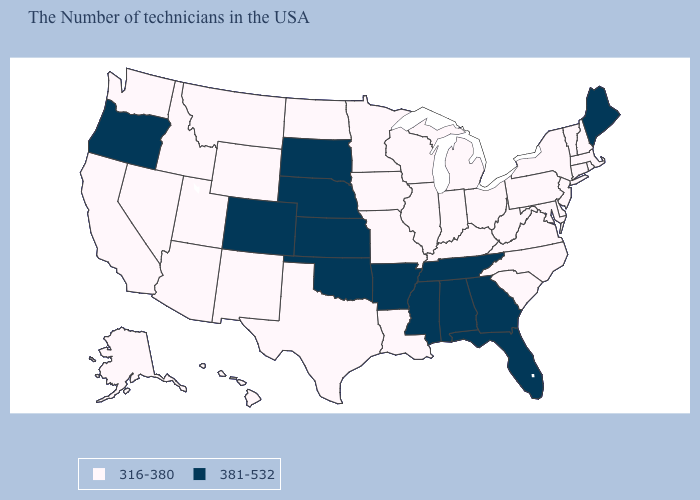What is the lowest value in the West?
Give a very brief answer. 316-380. Is the legend a continuous bar?
Concise answer only. No. Name the states that have a value in the range 316-380?
Concise answer only. Massachusetts, Rhode Island, New Hampshire, Vermont, Connecticut, New York, New Jersey, Delaware, Maryland, Pennsylvania, Virginia, North Carolina, South Carolina, West Virginia, Ohio, Michigan, Kentucky, Indiana, Wisconsin, Illinois, Louisiana, Missouri, Minnesota, Iowa, Texas, North Dakota, Wyoming, New Mexico, Utah, Montana, Arizona, Idaho, Nevada, California, Washington, Alaska, Hawaii. What is the value of Tennessee?
Give a very brief answer. 381-532. Which states hav the highest value in the MidWest?
Answer briefly. Kansas, Nebraska, South Dakota. How many symbols are there in the legend?
Quick response, please. 2. What is the value of Colorado?
Keep it brief. 381-532. What is the highest value in the USA?
Quick response, please. 381-532. Name the states that have a value in the range 316-380?
Concise answer only. Massachusetts, Rhode Island, New Hampshire, Vermont, Connecticut, New York, New Jersey, Delaware, Maryland, Pennsylvania, Virginia, North Carolina, South Carolina, West Virginia, Ohio, Michigan, Kentucky, Indiana, Wisconsin, Illinois, Louisiana, Missouri, Minnesota, Iowa, Texas, North Dakota, Wyoming, New Mexico, Utah, Montana, Arizona, Idaho, Nevada, California, Washington, Alaska, Hawaii. What is the lowest value in the USA?
Concise answer only. 316-380. Which states have the lowest value in the Northeast?
Concise answer only. Massachusetts, Rhode Island, New Hampshire, Vermont, Connecticut, New York, New Jersey, Pennsylvania. Does South Carolina have the highest value in the South?
Write a very short answer. No. Does the first symbol in the legend represent the smallest category?
Concise answer only. Yes. 